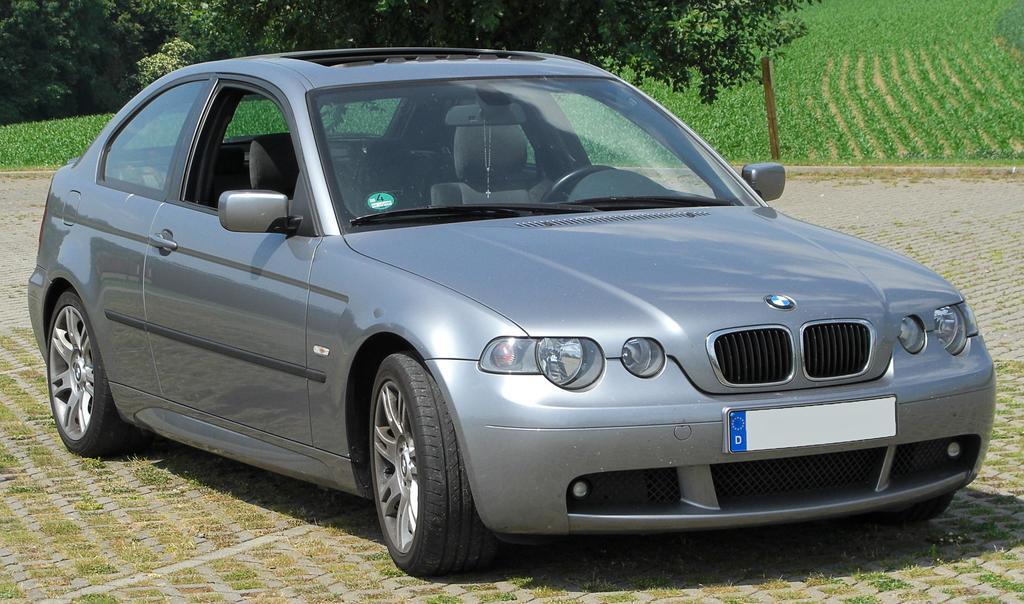Can you describe this image briefly? In this image I can see a car on the ground. In the background there is a field and also I can see many trees. 